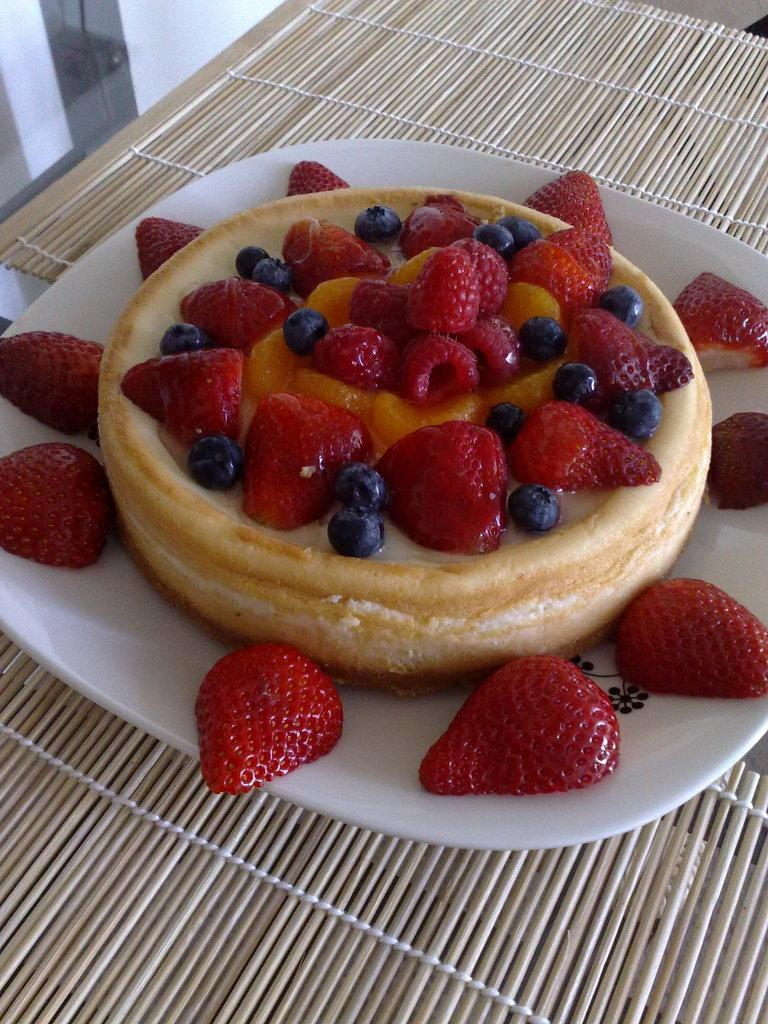What type of food is visible in the image? There is a pancake with strawberries in the image. What color is the plate that the pancake is on? The plate is white in color. What material is the surface that the plate is placed on? The plate is placed on a wooden surface. What company manufactures the strawberries in the image? There is no information about the company that manufactures the strawberries in the image. 